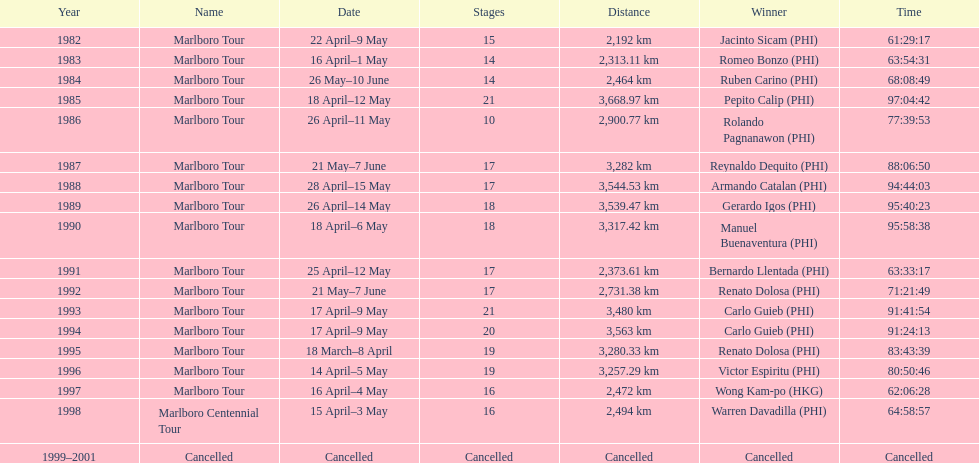Who won the most marlboro tours? Carlo Guieb. 